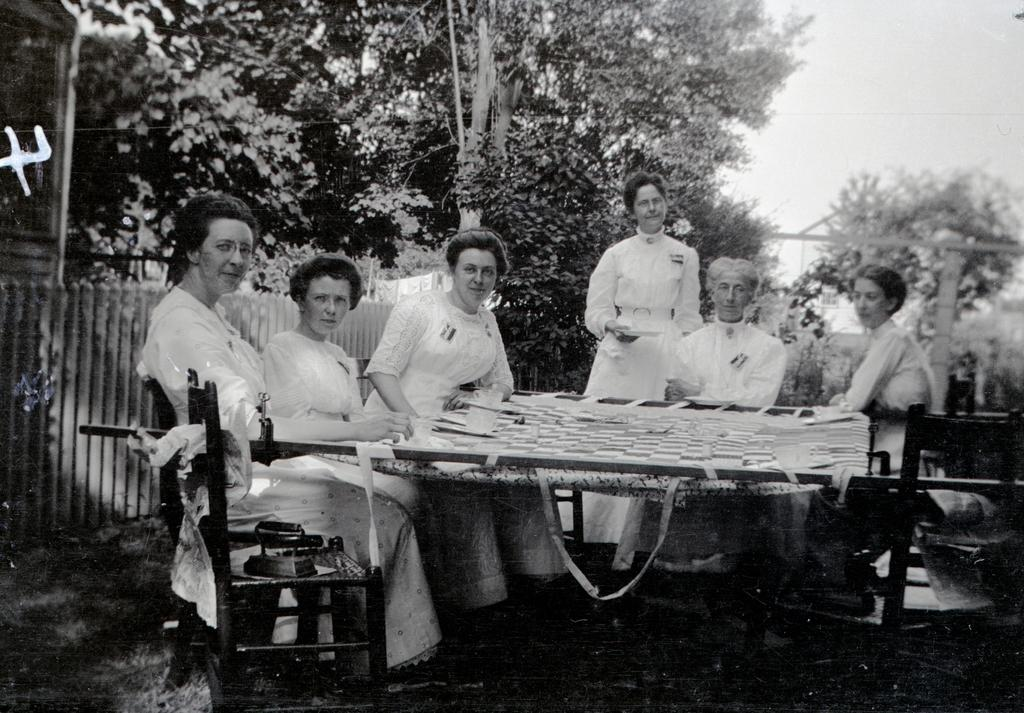How many women are present in the image? There are 6 women in the image. What are the positions of the women in the image? Five of the women are sitting, and one of the women is standing. What can be seen in the image besides the women? There is a railing in the image. What is visible in the background of the image? There are trees and the sky visible in the background of the image. What type of scent can be detected from the fairies in the image? There are no fairies present in the image, so it is not possible to detect any scent from them. 